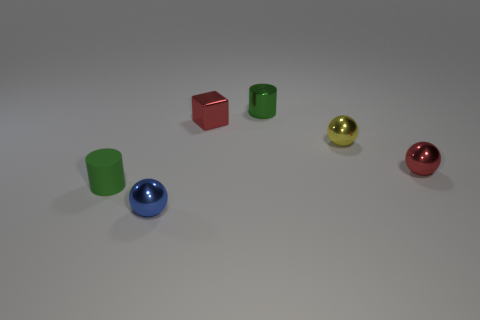The metal object that is the same color as the tiny block is what shape?
Your response must be concise. Sphere. What is the color of the cylinder behind the cylinder that is left of the tiny blue metal sphere?
Your answer should be very brief. Green. Is the size of the yellow ball the same as the metallic cylinder?
Provide a short and direct response. Yes. What number of blocks are either small shiny things or blue objects?
Keep it short and to the point. 1. There is a green object on the left side of the red cube; what number of cubes are in front of it?
Your answer should be compact. 0. Does the small yellow thing have the same shape as the tiny blue shiny thing?
Offer a terse response. Yes. There is a metal thing that is the same shape as the rubber thing; what is its size?
Provide a succinct answer. Small. What is the shape of the small green object that is left of the blue metal ball that is in front of the small red shiny ball?
Provide a succinct answer. Cylinder. The red metallic sphere is what size?
Provide a succinct answer. Small. The matte object is what shape?
Ensure brevity in your answer.  Cylinder. 